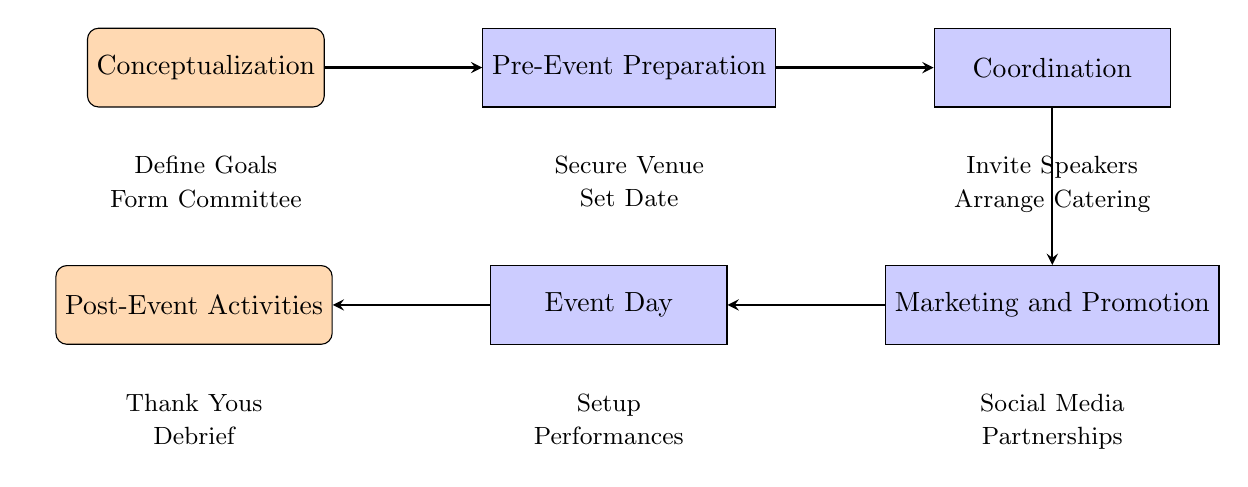What is the first stage in the event planning process? The first stage in the diagram is labeled as "Conceptualization." It is the first node that appears in the flow from left to right.
Answer: Conceptualization How many main stages are there in the planning process? The diagram shows five main stages flowing from left to right, confirming that there are five distinct stages outlined.
Answer: Five What activities are included in the "Event Day" stage? Under the "Event Day" node, there are multiple elements listed including "Setup," "Performances," which are the activities for this stage.
Answer: Setup, Performances Which node follows "Coordination" in the process? The flow diagram indicates that the node directly following "Coordination" is "Marketing and Promotion." This can be determined by observing the arrow leading to the next stage down the flow.
Answer: Marketing and Promotion What is the last stage of the event planning process? The last stage shown in the flowchart is "Post-Event Activities," which is the last node on the far left of the diagram after all previous stages have been executed.
Answer: Post-Event Activities What type of activities are performed during the "Pre-Event Preparation"? The "Pre-Event Preparation" stage includes elements like "Secure Venue" and "Set Date". This is derived from the nodes located directly below this stage label in the diagram.
Answer: Secure Venue, Set Date Which element is involved in the "Marketing and Promotion" stage? In the "Marketing and Promotion" stage, one of the activities listed is "Social Media," which points to the promotional strategies associated with this stage.
Answer: Social Media What is the flow direction of the process? The flow of the diagram moves horizontally from left to right and then culminates in a downward flow, representing the sequence of planning stages leading to the event execution.
Answer: Left to right How are the activities structured under each stage? Each stage is detailed with specific activities that contribute to that phase, forming a hierarchy of tasks that need to be accomplished before proceeding to the next stage in the diagram-based process.
Answer: Hierarchical structure 